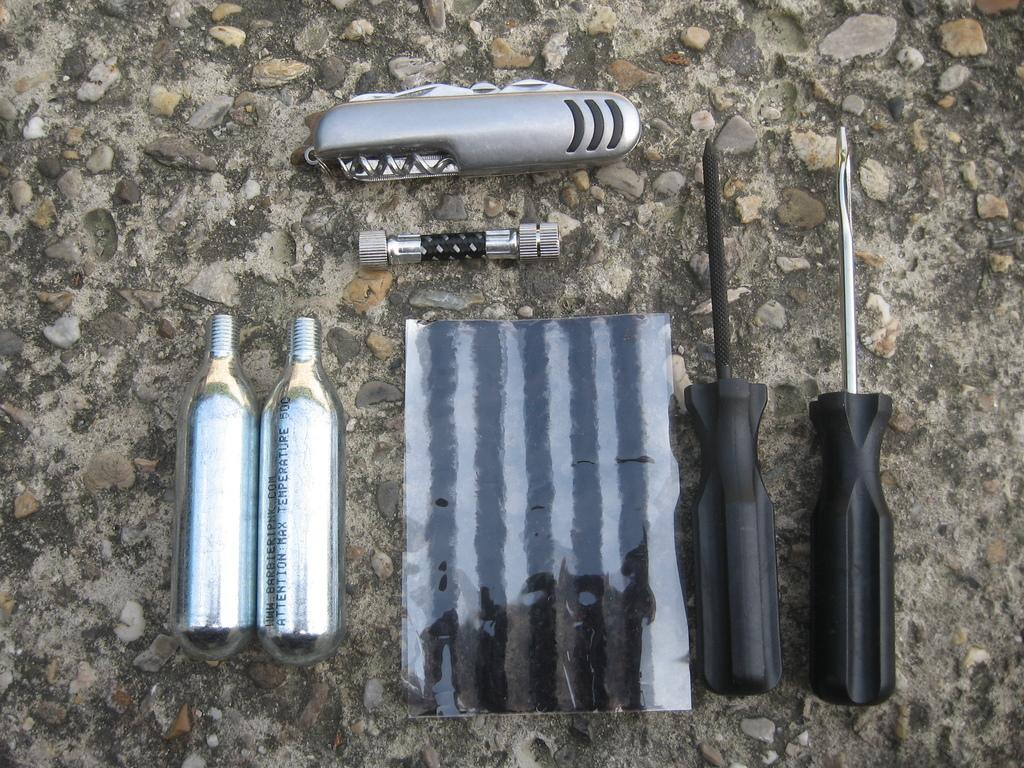What type of tools can be seen in the image? There are screwdrivers, a cutting tool, and a bolt in the image. What other object is present in the image? There is a metal piece and a nut in the image. How many fixtures are in the image? There are two fixtures in the image. Where are all these objects located? All of these objects are on the floor. What type of punishment is being administered in the image? There is no punishment being administered in the image; it features tools and objects related to construction or repair. Can you see a tramp performing in the image? There is no tramp performing in the image; it features tools and objects related to construction or repair. 